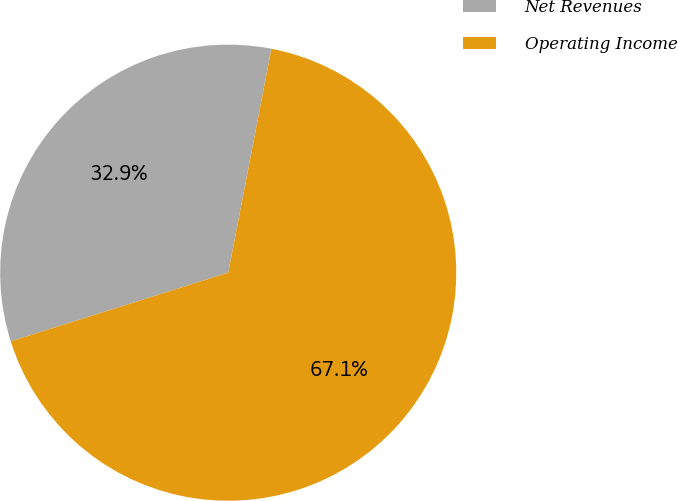Convert chart to OTSL. <chart><loc_0><loc_0><loc_500><loc_500><pie_chart><fcel>Net Revenues<fcel>Operating Income<nl><fcel>32.9%<fcel>67.1%<nl></chart> 